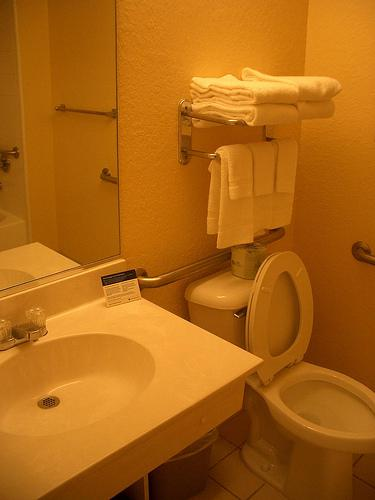Question: why does everything look orange?
Choices:
A. The time of day.
B. Bad film.
C. Bad photographer.
D. The lighting.
Answer with the letter. Answer: D Question: where is the sink in the photo?
Choices:
A. By the microwave.
B. Near the counter.
C. Bottom left corner.
D. By the stove.
Answer with the letter. Answer: C Question: how many sink handles are shown?
Choices:
A. Two.
B. Three.
C. Four.
D. One.
Answer with the letter. Answer: A Question: how many towels are shown?
Choices:
A. Eight.
B. Six.
C. Ten.
D. Four.
Answer with the letter. Answer: C 